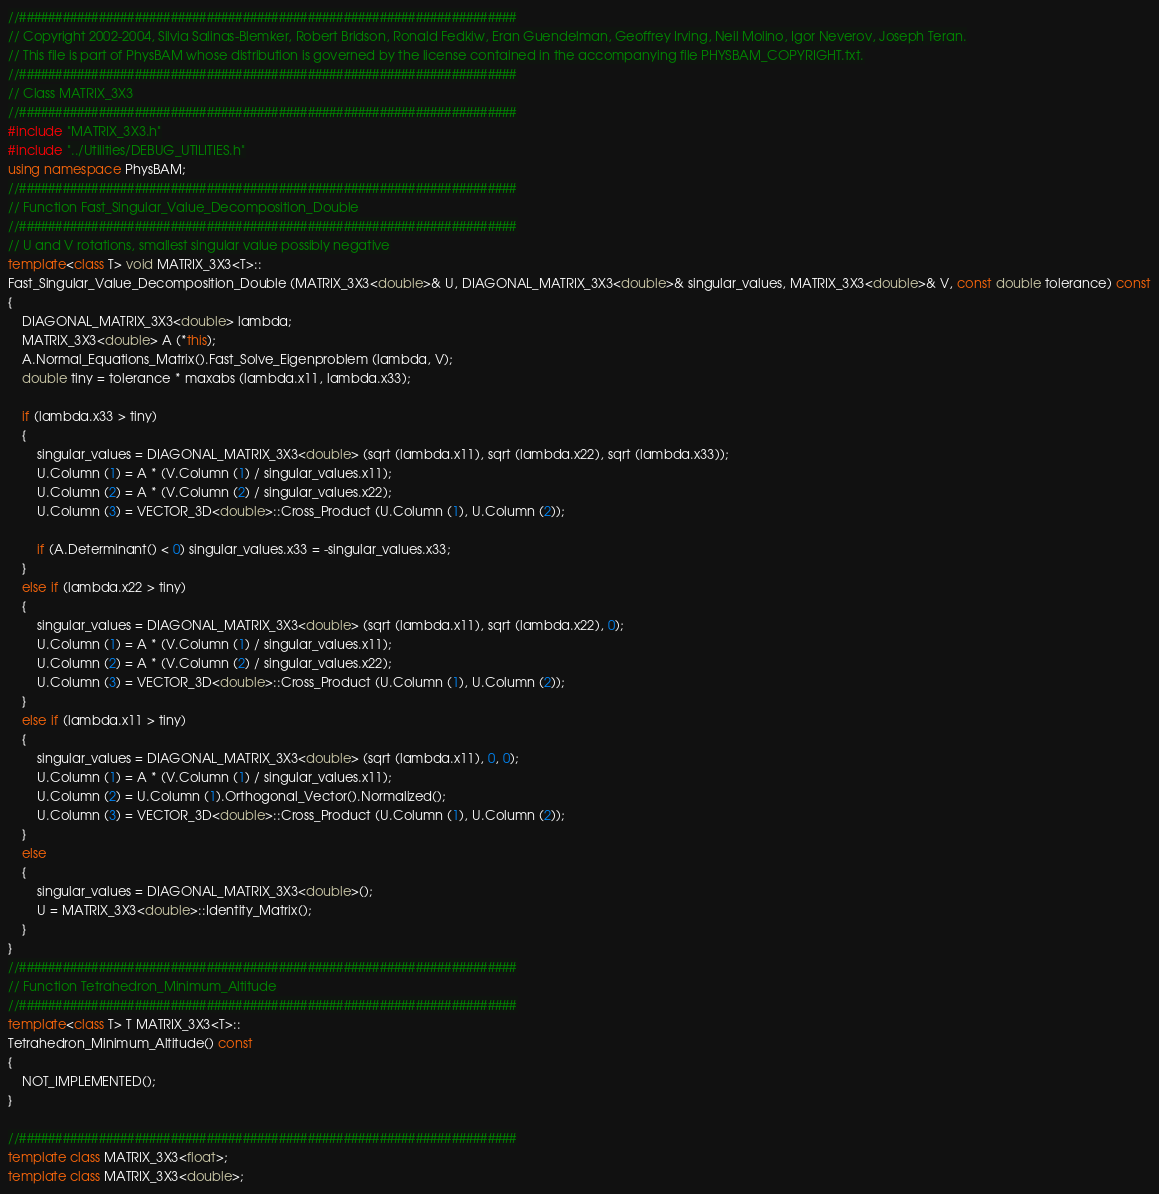<code> <loc_0><loc_0><loc_500><loc_500><_C++_>//#####################################################################
// Copyright 2002-2004, Silvia Salinas-Blemker, Robert Bridson, Ronald Fedkiw, Eran Guendelman, Geoffrey Irving, Neil Molino, Igor Neverov, Joseph Teran.
// This file is part of PhysBAM whose distribution is governed by the license contained in the accompanying file PHYSBAM_COPYRIGHT.txt.
//#####################################################################
// Class MATRIX_3X3
//#####################################################################
#include "MATRIX_3X3.h"
#include "../Utilities/DEBUG_UTILITIES.h"
using namespace PhysBAM;
//#####################################################################
// Function Fast_Singular_Value_Decomposition_Double
//#####################################################################
// U and V rotations, smallest singular value possibly negative
template<class T> void MATRIX_3X3<T>::
Fast_Singular_Value_Decomposition_Double (MATRIX_3X3<double>& U, DIAGONAL_MATRIX_3X3<double>& singular_values, MATRIX_3X3<double>& V, const double tolerance) const
{
	DIAGONAL_MATRIX_3X3<double> lambda;
	MATRIX_3X3<double> A (*this);
	A.Normal_Equations_Matrix().Fast_Solve_Eigenproblem (lambda, V);
	double tiny = tolerance * maxabs (lambda.x11, lambda.x33);

	if (lambda.x33 > tiny)
	{
		singular_values = DIAGONAL_MATRIX_3X3<double> (sqrt (lambda.x11), sqrt (lambda.x22), sqrt (lambda.x33));
		U.Column (1) = A * (V.Column (1) / singular_values.x11);
		U.Column (2) = A * (V.Column (2) / singular_values.x22);
		U.Column (3) = VECTOR_3D<double>::Cross_Product (U.Column (1), U.Column (2));

		if (A.Determinant() < 0) singular_values.x33 = -singular_values.x33;
	}
	else if (lambda.x22 > tiny)
	{
		singular_values = DIAGONAL_MATRIX_3X3<double> (sqrt (lambda.x11), sqrt (lambda.x22), 0);
		U.Column (1) = A * (V.Column (1) / singular_values.x11);
		U.Column (2) = A * (V.Column (2) / singular_values.x22);
		U.Column (3) = VECTOR_3D<double>::Cross_Product (U.Column (1), U.Column (2));
	}
	else if (lambda.x11 > tiny)
	{
		singular_values = DIAGONAL_MATRIX_3X3<double> (sqrt (lambda.x11), 0, 0);
		U.Column (1) = A * (V.Column (1) / singular_values.x11);
		U.Column (2) = U.Column (1).Orthogonal_Vector().Normalized();
		U.Column (3) = VECTOR_3D<double>::Cross_Product (U.Column (1), U.Column (2));
	}
	else
	{
		singular_values = DIAGONAL_MATRIX_3X3<double>();
		U = MATRIX_3X3<double>::Identity_Matrix();
	}
}
//#####################################################################
// Function Tetrahedron_Minimum_Altitude
//#####################################################################
template<class T> T MATRIX_3X3<T>::
Tetrahedron_Minimum_Altitude() const
{
	NOT_IMPLEMENTED();
}

//#####################################################################
template class MATRIX_3X3<float>;
template class MATRIX_3X3<double>;
</code> 